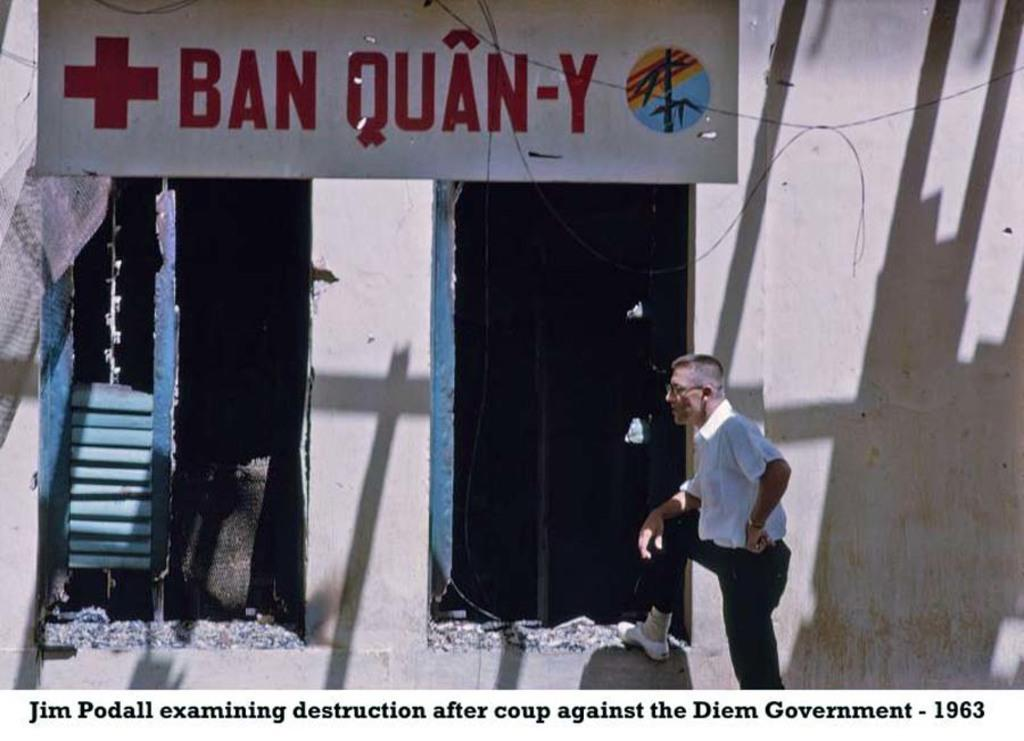Who is present in the image? There is a man in the image. What can be seen in the background of the image? There is a wall in the background of the image. How many doors are on the wall? There are two doors on the wall. What is hanging at the top of the wall? There is a banner at the top of the wall. What is written at the bottom of the wall? There is text written at the bottom of the wall. What direction is the pail being used in the image? There is no pail present in the image. How is the whip being used in the image? There is no whip present in the image. 